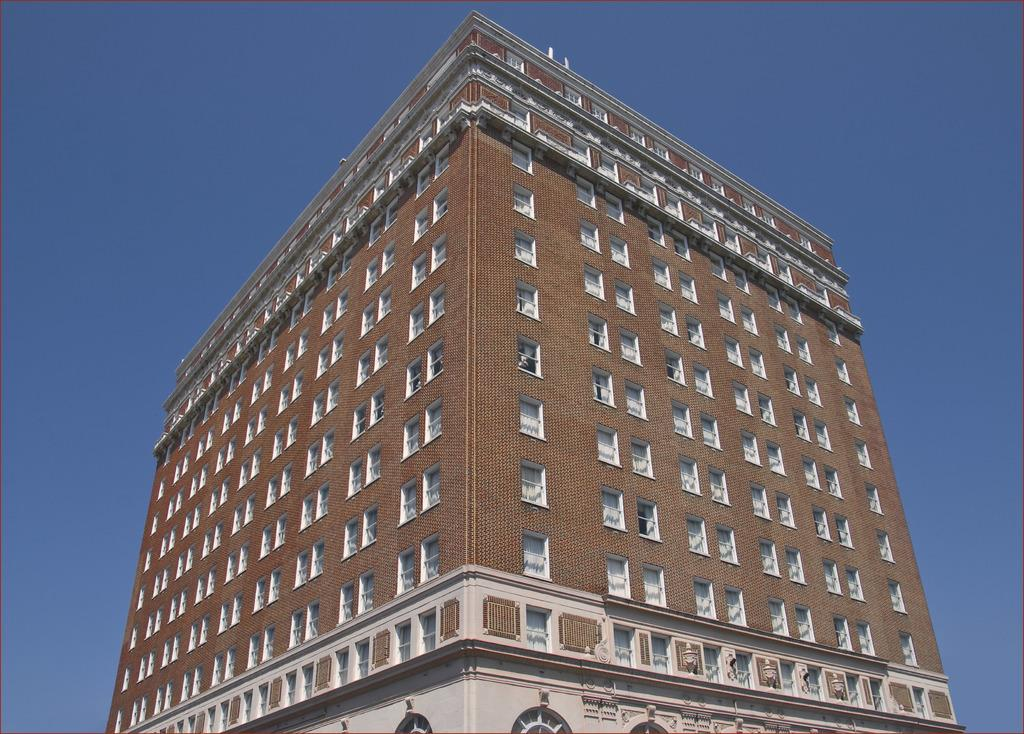What type of structure is present in the image? There is a building in the image. What colors can be seen on the building? The building has brown and white colors. How many windows are visible on the building? The building has many windows. What is visible in the background of the image? The sky is visible in the background of the image. What color is the sky in the image? The sky is blue in color. How many geese are sitting on the cloth in the image? There are no geese or cloth present in the image. What date is marked on the calendar in the image? There is no calendar present in the image. 